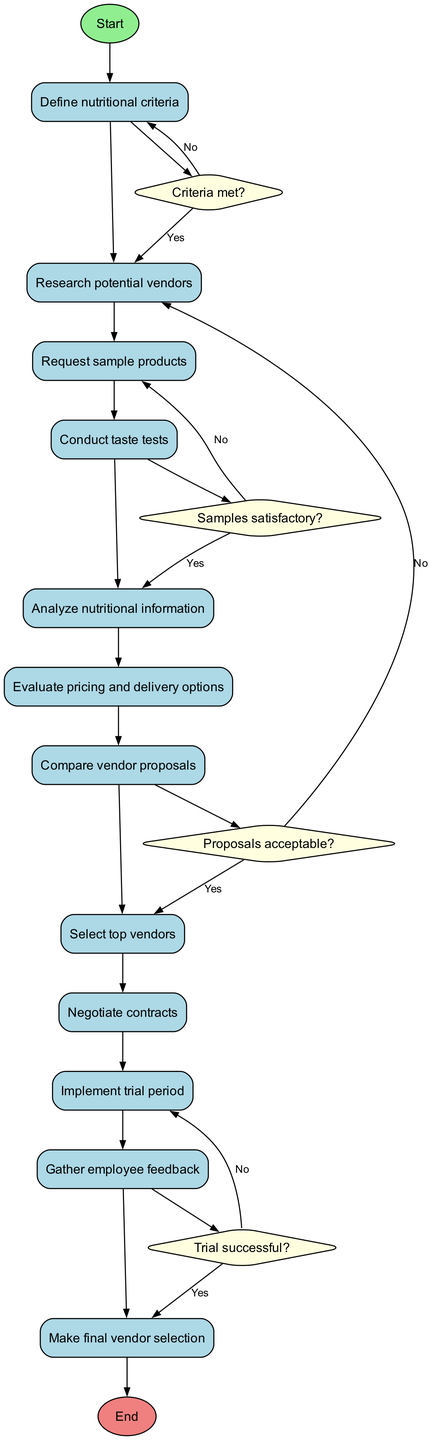What are the nodes present in the diagram? The nodes present in the diagram include Start, Define nutritional criteria, Research potential vendors, Request sample products, Conduct taste tests, Analyze nutritional information, Evaluate pricing and delivery options, Compare vendor proposals, Select top vendors, Negotiate contracts, Implement trial period, Gather employee feedback, Make final vendor selection, and End.
Answer: Start, Define nutritional criteria, Research potential vendors, Request sample products, Conduct taste tests, Analyze nutritional information, Evaluate pricing and delivery options, Compare vendor proposals, Select top vendors, Negotiate contracts, Implement trial period, Gather employee feedback, Make final vendor selection, End How many edges are there in the diagram? Each of the nodes, except for the Start and End nodes, is connected by the edges shown in the diagram. Counting these connections, there are a total of 12 edges.
Answer: 12 Which node follows the "Analyze nutritional information" node? The node that follows "Analyze nutritional information" in the flow of the diagram is "Evaluate pricing and delivery options." This connection indicates the next step in the evaluation process.
Answer: Evaluate pricing and delivery options What happens if the criteria are not met? If the criteria are not met, the flow goes back to the "Define nutritional criteria" node, indicating that the criteria need to be revised before proceeding with the research on potential vendors.
Answer: Revise criteria What is the final outcome if the trial is not successful? If the trial period is not successful, the outcome is that the process would return to the "Implement trial period" node, implying that further attempts are necessary before making a final selection.
Answer: Implement trial period How many decision points are there in the diagram? The diagram contains four decision points: "Criteria met?", "Samples satisfactory?", "Proposals acceptable?", and "Trial successful?", each determining the next steps based on specific conditions.
Answer: 4 What is the role of employee feedback in the process? Employee feedback plays a crucial role after implementing the trial period, as it influences the final vendor selection based on employee satisfaction and preferences regarding the snacks.
Answer: Gather employee feedback What is the first step in the process? The first step in the process is to "Define nutritional criteria," which sets the foundation for evaluating potential snack vendors based on predetermined health guidelines.
Answer: Define nutritional criteria 